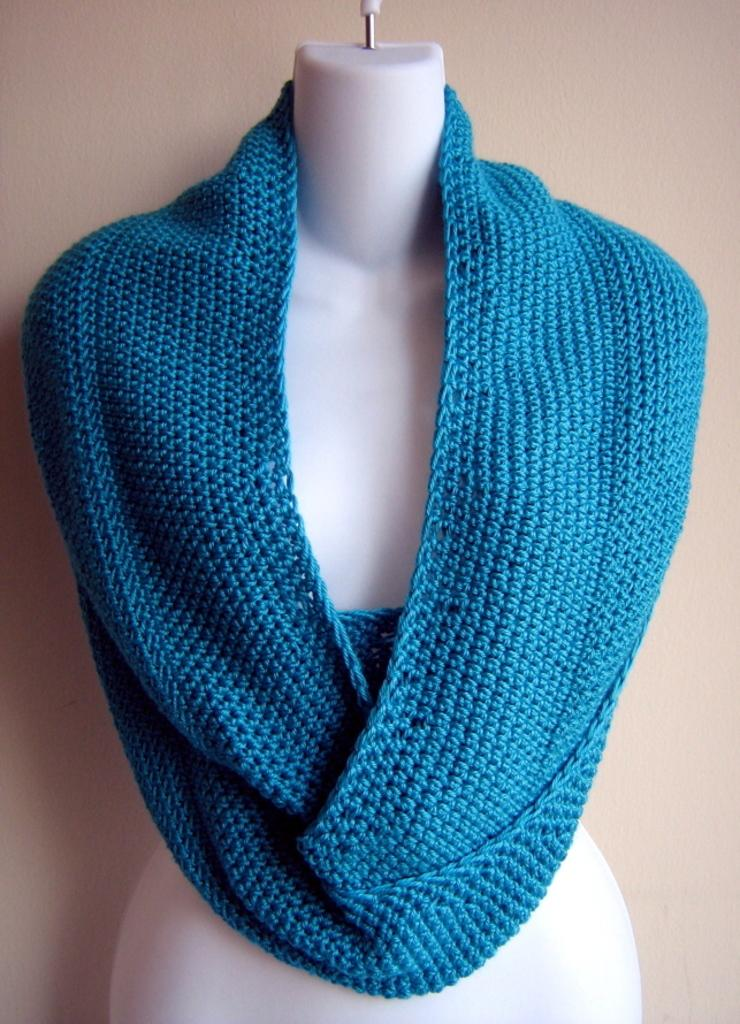What is placed on the mannequin in the image? There is a cloth on a mannequin in the image. What language is the mannequin speaking in the image? Mannequins do not speak, so there is no language present in the image. 